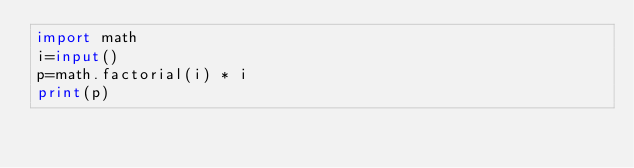Convert code to text. <code><loc_0><loc_0><loc_500><loc_500><_Python_>import math
i=input()
p=math.factorial(i) * i
print(p)</code> 